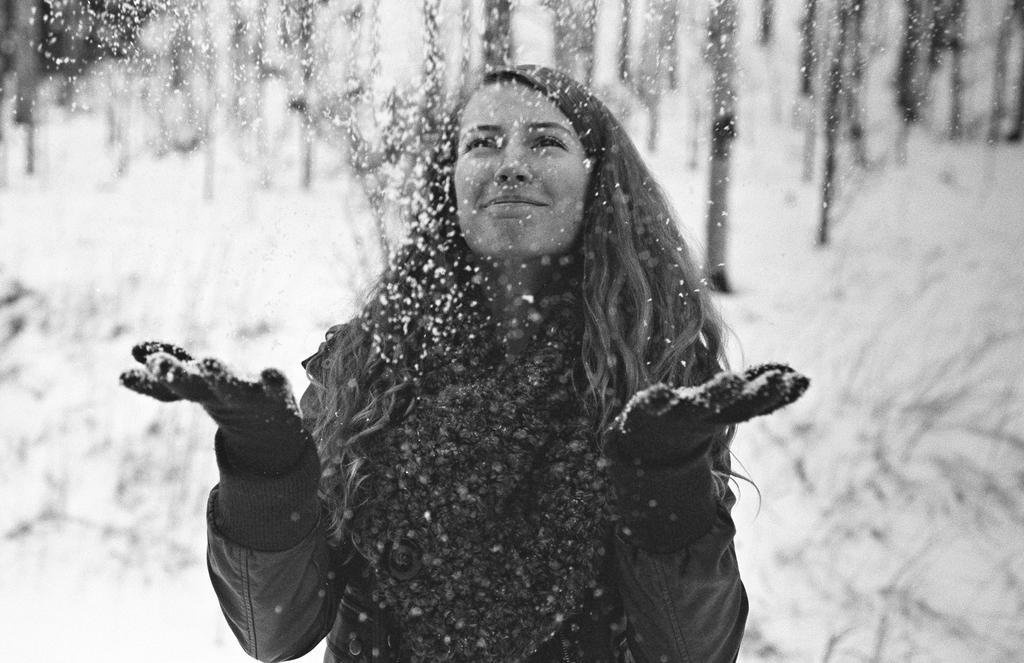Please provide a concise description of this image. A woman is playing with the snow, she wore coat. This is the snow, this image is in black and white color. 